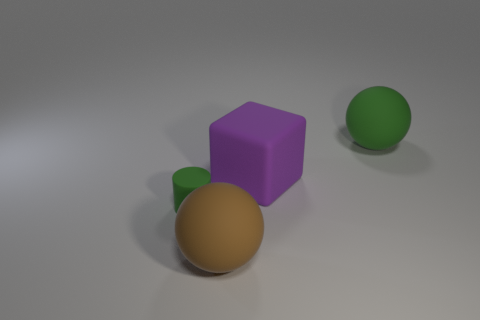How many metallic objects are the same color as the tiny rubber cylinder?
Make the answer very short. 0. What is the color of the sphere that is on the right side of the ball that is in front of the rubber object right of the block?
Offer a terse response. Green. Is the big purple thing made of the same material as the green ball?
Give a very brief answer. Yes. Does the purple matte thing have the same shape as the brown thing?
Offer a very short reply. No. Are there the same number of big purple rubber cubes that are on the right side of the large purple cube and large brown spheres that are in front of the brown thing?
Your answer should be very brief. Yes. There is a tiny thing that is the same material as the large purple thing; what color is it?
Offer a terse response. Green. How many cubes are the same material as the big green thing?
Your response must be concise. 1. There is a small rubber cylinder in front of the rubber cube; is it the same color as the large cube?
Make the answer very short. No. What number of other brown objects have the same shape as the large brown object?
Ensure brevity in your answer.  0. Is the number of big matte things in front of the rubber block the same as the number of big brown matte balls?
Keep it short and to the point. Yes. 